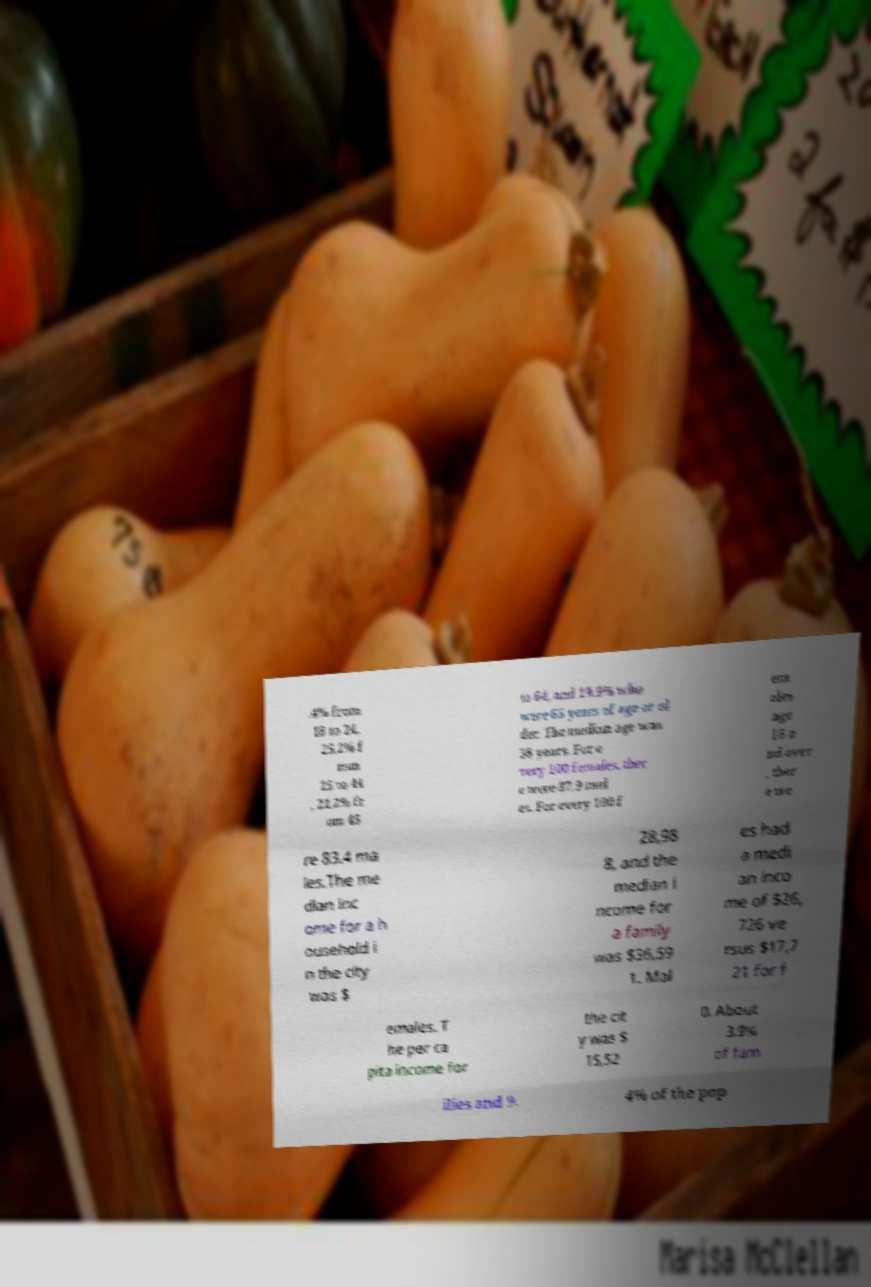I need the written content from this picture converted into text. Can you do that? .4% from 18 to 24, 25.2% f rom 25 to 44 , 21.2% fr om 45 to 64, and 19.9% who were 65 years of age or ol der. The median age was 38 years. For e very 100 females, ther e were 87.9 mal es. For every 100 f em ales age 18 a nd over , ther e we re 83.4 ma les.The me dian inc ome for a h ousehold i n the city was $ 28,98 8, and the median i ncome for a family was $36,59 1. Mal es had a medi an inco me of $26, 726 ve rsus $17,7 21 for f emales. T he per ca pita income for the cit y was $ 15,52 0. About 3.9% of fam ilies and 9. 4% of the pop 